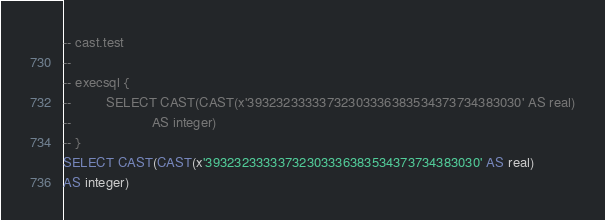Convert code to text. <code><loc_0><loc_0><loc_500><loc_500><_SQL_>-- cast.test
-- 
-- execsql {
--         SELECT CAST(CAST(x'39323233333732303336383534373734383030' AS real)
--                     AS integer)
-- }
SELECT CAST(CAST(x'39323233333732303336383534373734383030' AS real)
AS integer)</code> 